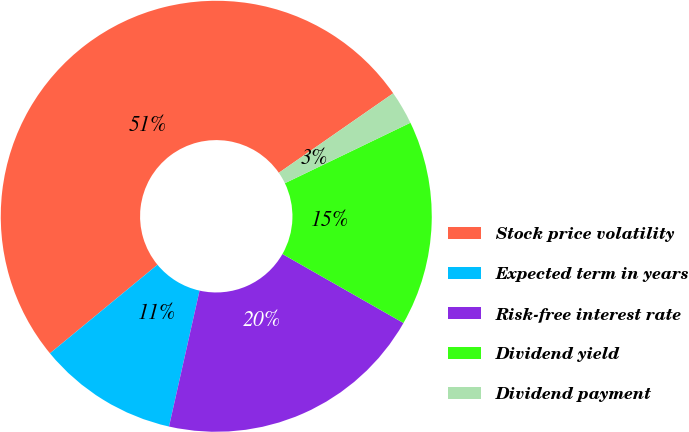<chart> <loc_0><loc_0><loc_500><loc_500><pie_chart><fcel>Stock price volatility<fcel>Expected term in years<fcel>Risk-free interest rate<fcel>Dividend yield<fcel>Dividend payment<nl><fcel>51.3%<fcel>10.51%<fcel>20.27%<fcel>15.39%<fcel>2.52%<nl></chart> 